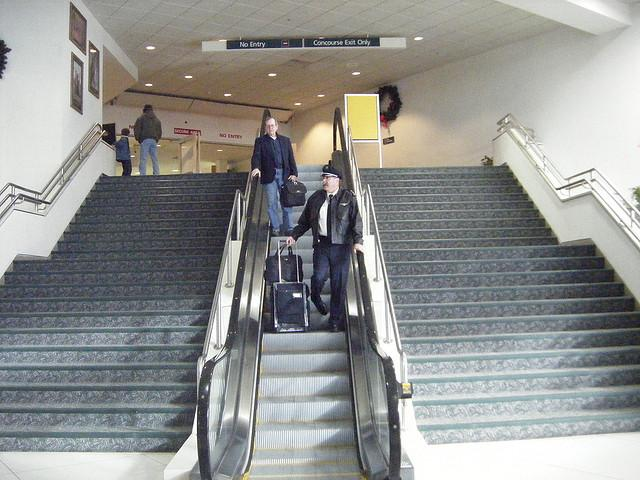Where are the two old men located in?

Choices:
A) train station
B) ferry station
C) shopping mall
D) airport airport 